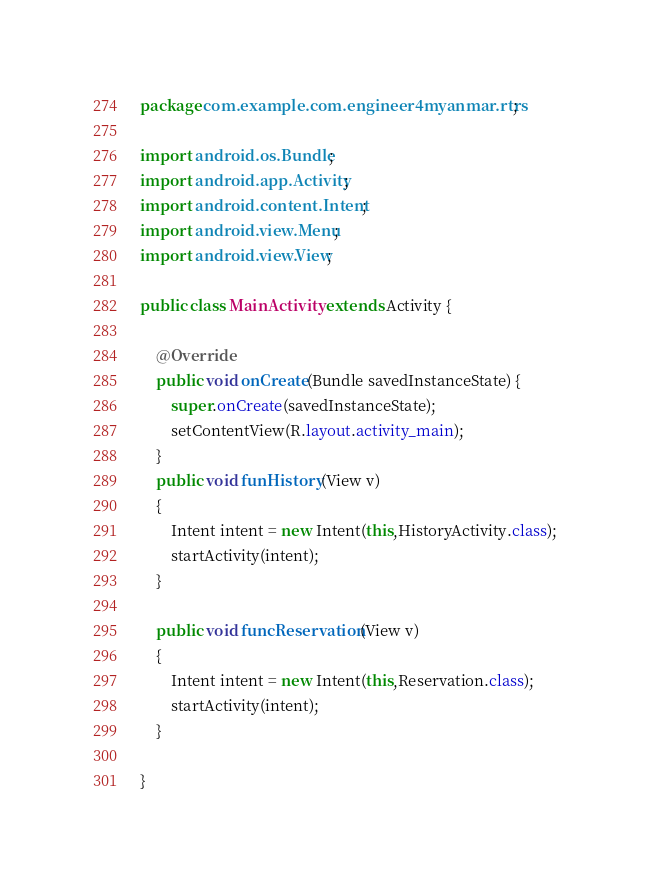Convert code to text. <code><loc_0><loc_0><loc_500><loc_500><_Java_>package com.example.com.engineer4myanmar.rtrs;

import android.os.Bundle;
import android.app.Activity;
import android.content.Intent;
import android.view.Menu;
import android.view.View;

public class MainActivity extends Activity {

    @Override
    public void onCreate(Bundle savedInstanceState) {
        super.onCreate(savedInstanceState);
        setContentView(R.layout.activity_main);
    }
    public void funHistory(View v)
    {
    	Intent intent = new Intent(this,HistoryActivity.class);
    	startActivity(intent);
    }
    
    public void funcReservation(View v)
    {
    	Intent intent = new Intent(this,Reservation.class);
    	startActivity(intent);
    }
  
}
</code> 